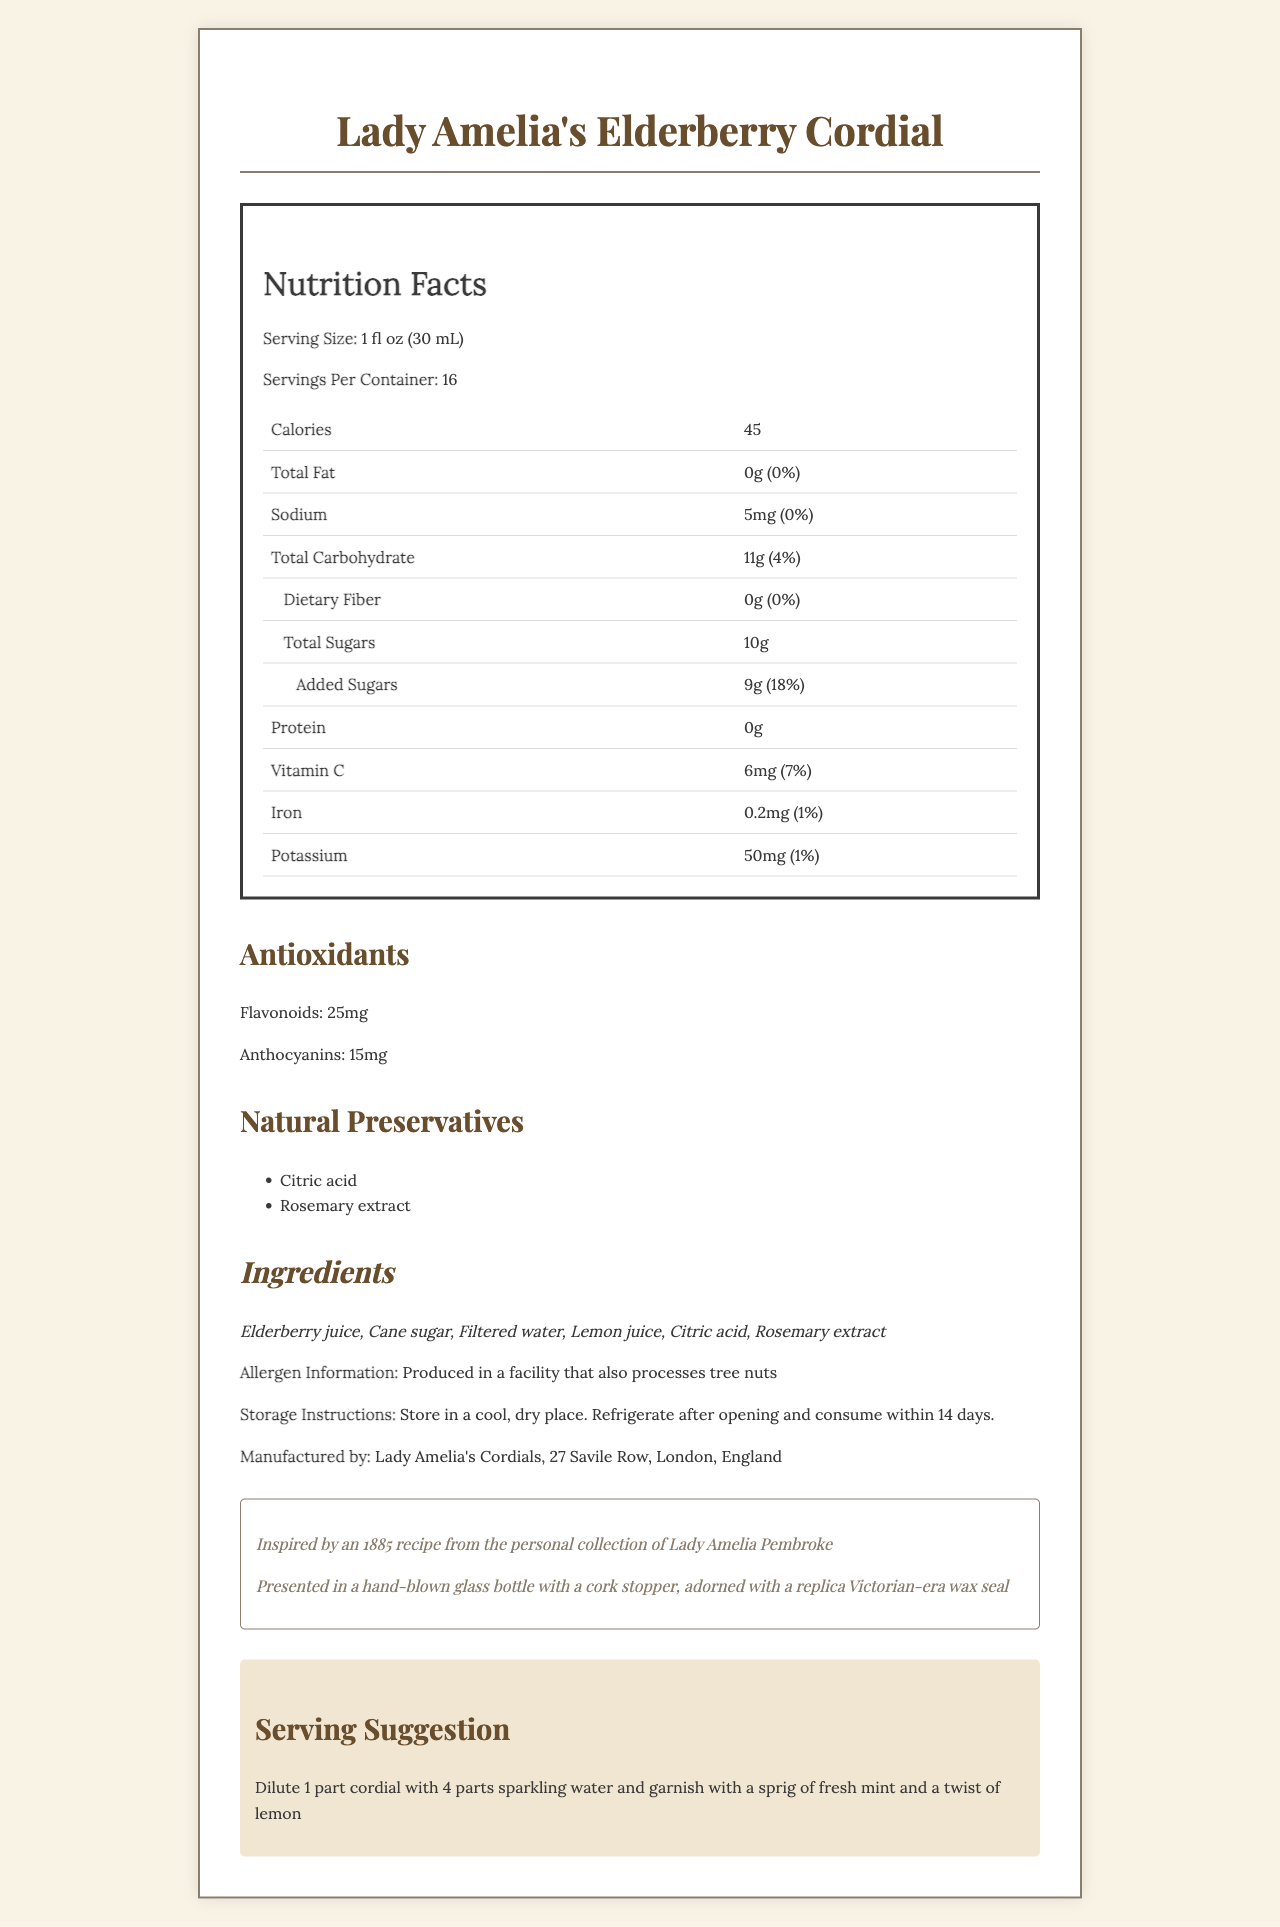what is the serving size for Lady Amelia's Elderberry Cordial? The serving size is listed as "1 fl oz (30 mL)" under Nutrition Facts.
Answer: 1 fl oz (30 mL) how many calories are in one serving? According to the Nutrition Facts section, each serving has 45 calories.
Answer: 45 which natural preservatives are used in this cordial? The section on Natural Preservatives lists Citric acid and Rosemary extract.
Answer: Citric acid, Rosemary extract what is the total carbohydrate content in one serving? The total carbohydrate content per serving is listed as 11g in the Nutrition Facts table.
Answer: 11g how should this cordial be stored after opening? The Storage Instructions state that it should be refrigerated after opening and consumed within 14 days.
Answer: Refrigerate after opening and consume within 14 days. how many grams of added sugars are there per serving? Under Total Sugars, it is specified that there are 9 grams of added sugars per serving.
Answer: 9g what information is given about allergens? The Allergen Information section says the product is produced in a facility that also processes tree nuts.
Answer: Produced in a facility that also processes tree nuts what does the serving suggestion recommend? The Serving Suggestion section suggests diluting 1 part cordial with 4 parts sparkling water and garnishing with fresh mint and lemon twist.
Answer: Dilute 1 part cordial with 4 parts sparkling water and garnish with a sprig of fresh mint and a twist of lemon who is the manufacturer of this cordial? The manufacturer is listed as Lady Amelia's Cordials, located at 27 Savile Row, London, England.
Answer: Lady Amelia's Cordials, 27 Savile Row, London, England how many servings are there per container? A. 10 B. 12 C. 14 D. 16 The document states there are 16 servings per container.
Answer: D which antioxidant is present in higher amounts in this cordial? I. Flavonoids II. Anthocyanins III. Vitamin C The documentation shows that Flavonoids are present in a higher amount (25mg) compared to Anthocyanins (15mg).
Answer: I does this cordial contain any dietary fiber? The Nutrition Facts section lists dietary fiber as 0g.
Answer: No describe the packaging of this cordial. The packaging details provided in the document mention a hand-blown glass bottle, cork stopper, and a Victorian-era wax seal.
Answer: This cordial is presented in a hand-blown glass bottle with a cork stopper, adorned with a replica Victorian-era wax seal. what is the source of the recipe for this cordial? Under Vintage Inspiration, it says the recipe is inspired by an 1885 recipe from Lady Amelia Pembroke.
Answer: Inspired by an 1885 recipe from the personal collection of Lady Amelia Pembroke can the amount of Vitamin C in each serving be determined from the document? The Nutrition Facts list Vitamin C content as 6mg per serving.
Answer: Yes how much potassium is in one serving? The Nutrition Facts table lists potassium content as 50mg per serving.
Answer: 50mg is this product gluten-free? The document does not provide information on whether the product is gluten-free.
Answer: Cannot be determined 